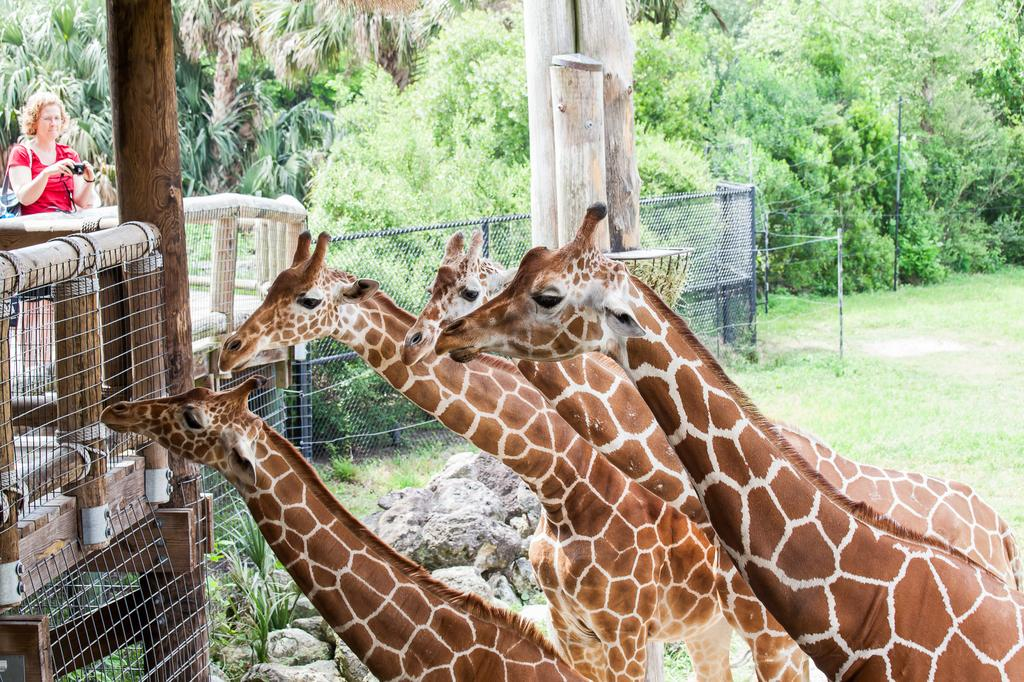What animals can be seen in the image? There are giraffes in the image. What type of barrier is present in the image? There is a fence in the image. What type of vegetation is visible in the image? There is grass and trees in the image. What is the woman wearing in the image? The woman is wearing a red dress in the image. What is the woman holding in the image? The woman is holding a camera in the image. On which side of the image is the woman located? The woman is on the left side of the image. What type of metal is the woman's dress made of in the image? The woman's dress is not made of metal; it is made of fabric, as indicated by the fact that it is a red dress. Can you tell me how many aunts are present in the image? There are no aunts mentioned or depicted in the image. 